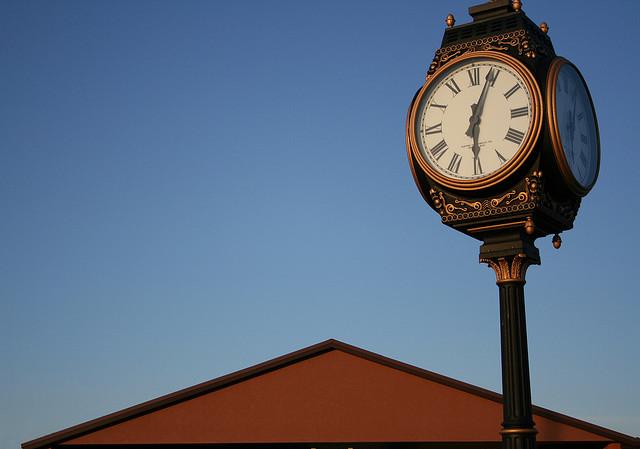Is the clock face in Roman numerals?
Quick response, please. Yes. What time does the clock show?
Answer briefly. 6:05. What time is it?
Short answer required. 6:04. What time does the clock say?
Be succinct. 6:05. 